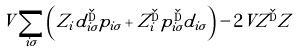<formula> <loc_0><loc_0><loc_500><loc_500>V \sum _ { i \sigma } \left ( Z _ { i } d _ { i \sigma } ^ { \dag } p _ { i \sigma } + Z _ { i } ^ { \dag } p _ { i \sigma } ^ { \dag } d _ { i \sigma } \right ) - 2 V Z ^ { \dag } Z</formula> 